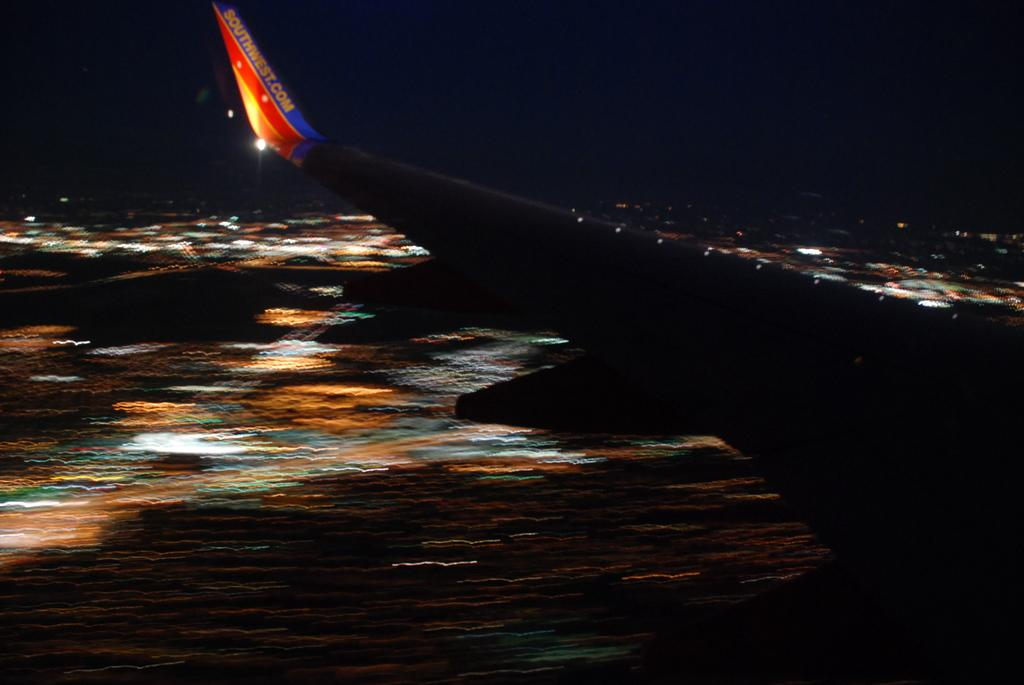<image>
Share a concise interpretation of the image provided. A Southwest airlines plane picture taken at night. 